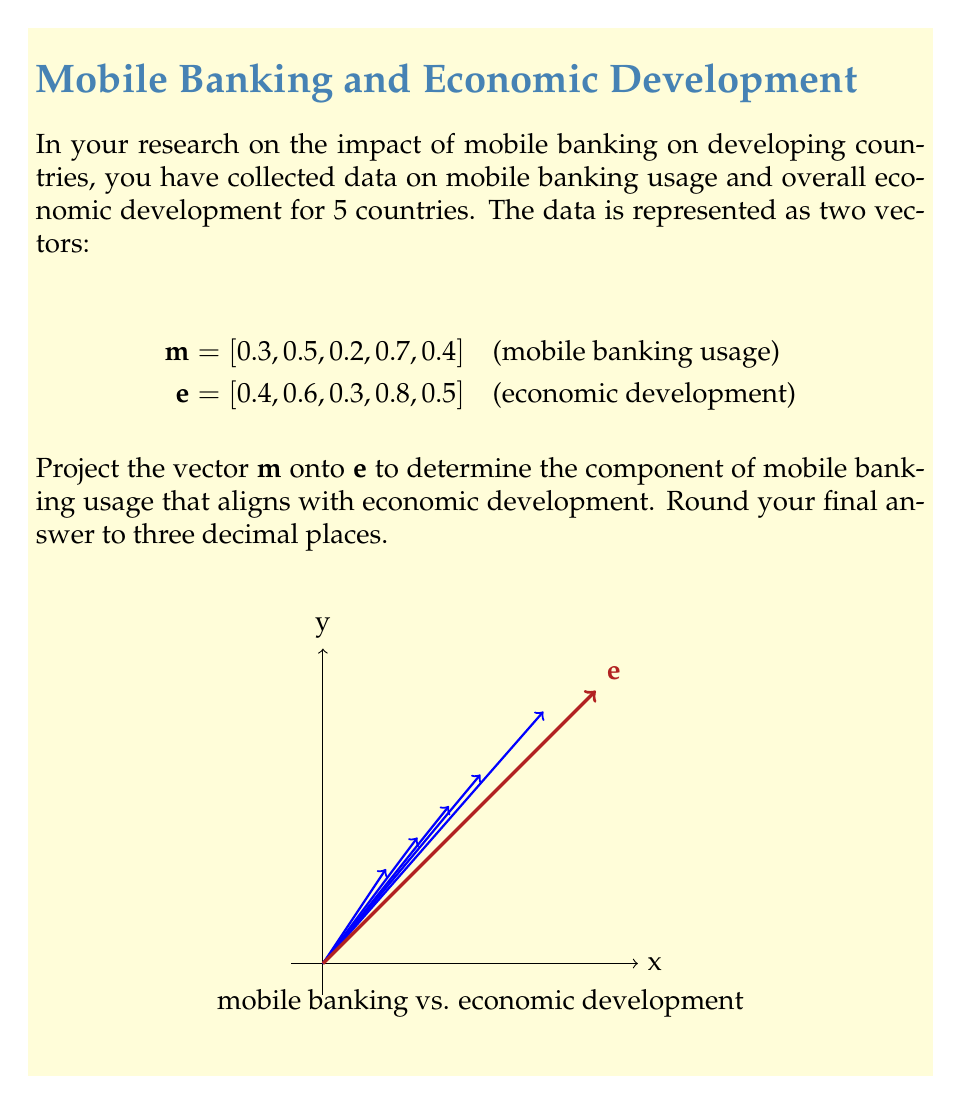Can you solve this math problem? To project vector $\mathbf{m}$ onto $\mathbf{e}$, we use the formula:

$$\text{proj}_\mathbf{e}\mathbf{m} = \frac{\mathbf{m} \cdot \mathbf{e}}{\|\mathbf{e}\|^2} \mathbf{e}$$

Step 1: Calculate the dot product $\mathbf{m} \cdot \mathbf{e}$
$$\mathbf{m} \cdot \mathbf{e} = (0.3)(0.4) + (0.5)(0.6) + (0.2)(0.3) + (0.7)(0.8) + (0.4)(0.5) = 1.31$$

Step 2: Calculate $\|\mathbf{e}\|^2$
$$\|\mathbf{e}\|^2 = 0.4^2 + 0.6^2 + 0.3^2 + 0.8^2 + 0.5^2 = 1.5$$

Step 3: Calculate the scalar projection
$$\frac{\mathbf{m} \cdot \mathbf{e}}{\|\mathbf{e}\|^2} = \frac{1.31}{1.5} = 0.873333$$

Step 4: Multiply the scalar projection by $\mathbf{e}$ to get the vector projection
$$\text{proj}_\mathbf{e}\mathbf{m} = 0.873333 [0.4, 0.6, 0.3, 0.8, 0.5]$$
$$= [0.349333, 0.524000, 0.262000, 0.698667, 0.436667]$$

Rounding to three decimal places:
$$\text{proj}_\mathbf{e}\mathbf{m} = [0.349, 0.524, 0.262, 0.699, 0.437]$$
Answer: $[0.349, 0.524, 0.262, 0.699, 0.437]$ 